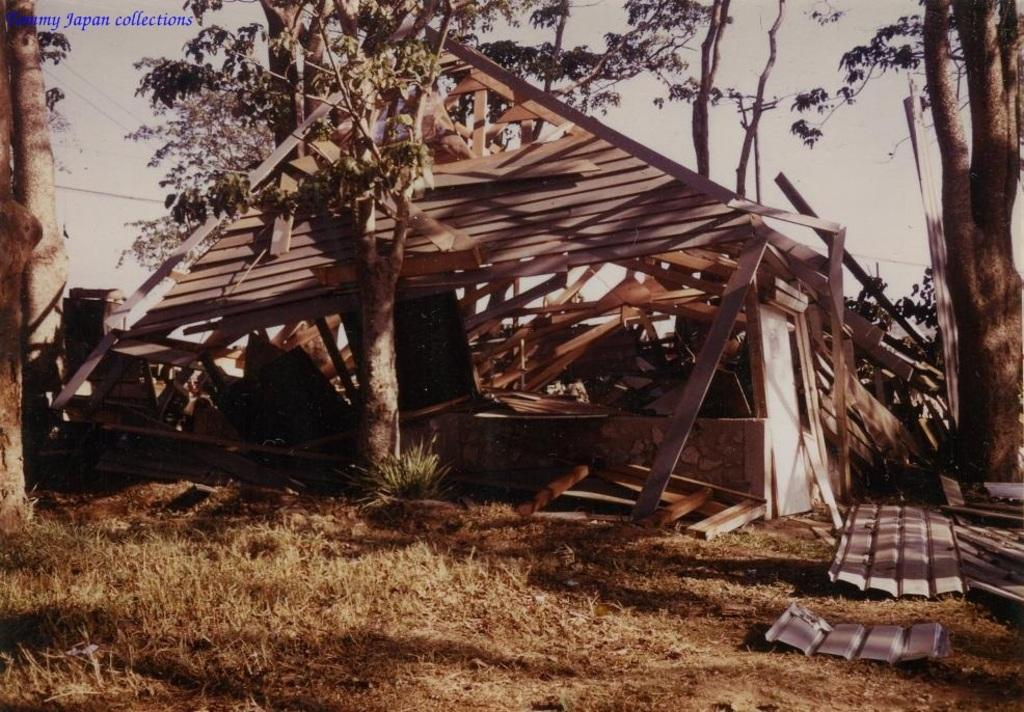What type of vegetation is present in the image? There are trees in the image. What kind of structure can be seen in the image? There is a wooden house in the image. What is the color of the sky in the image? The sky appears to be white in color. How many geese are flying over the wooden house in the image? There are no geese present in the image; it only features trees, a wooden house, and a white sky. What type of rod is used to support the wooden house in the image? There is no rod visible in the image; the wooden house appears to be standing on its own. 